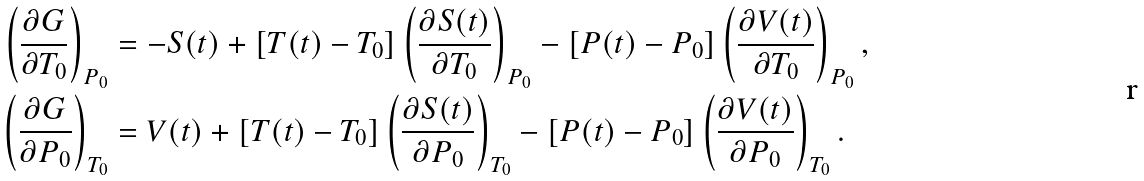Convert formula to latex. <formula><loc_0><loc_0><loc_500><loc_500>\left ( \frac { \partial G } { \partial T _ { 0 } } \right ) _ { P _ { 0 } } & = - S ( t ) + [ T ( t ) - T _ { 0 } ] \left ( \frac { \partial S ( t ) } { \partial T _ { 0 } } \right ) _ { P _ { 0 } } - [ P ( t ) - P _ { 0 } ] \left ( \frac { \partial V ( t ) } { \partial T _ { 0 } } \right ) _ { P _ { 0 } } , \\ \left ( \frac { \partial G } { \partial P _ { 0 } } \right ) _ { T _ { 0 } } & = V ( t ) + [ T ( t ) - T _ { 0 } ] \left ( \frac { \partial S ( t ) } { \partial P _ { 0 } } \right ) _ { T _ { 0 } } - [ P ( t ) - P _ { 0 } ] \left ( \frac { \partial V ( t ) } { \partial P _ { 0 } } \right ) _ { T _ { 0 } } .</formula> 